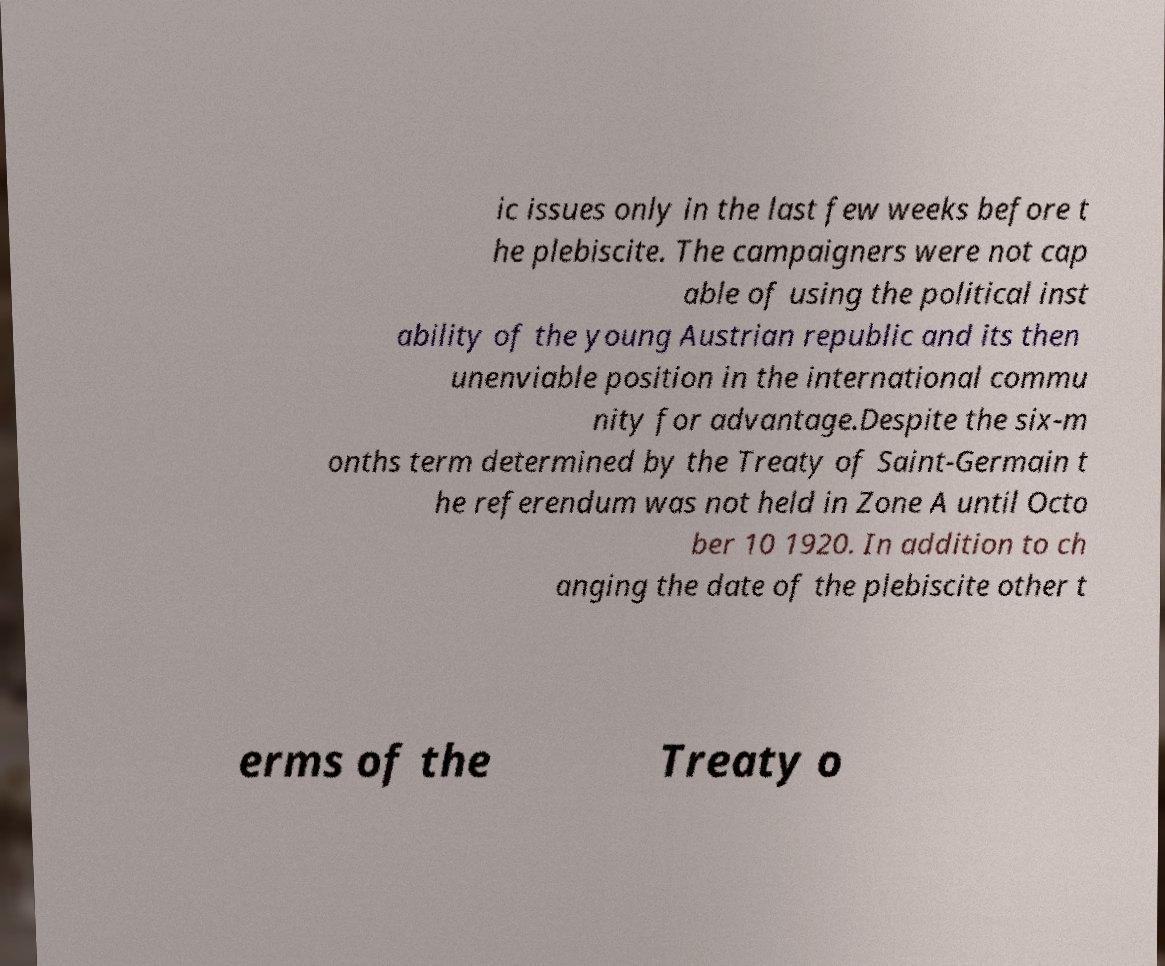For documentation purposes, I need the text within this image transcribed. Could you provide that? ic issues only in the last few weeks before t he plebiscite. The campaigners were not cap able of using the political inst ability of the young Austrian republic and its then unenviable position in the international commu nity for advantage.Despite the six-m onths term determined by the Treaty of Saint-Germain t he referendum was not held in Zone A until Octo ber 10 1920. In addition to ch anging the date of the plebiscite other t erms of the Treaty o 